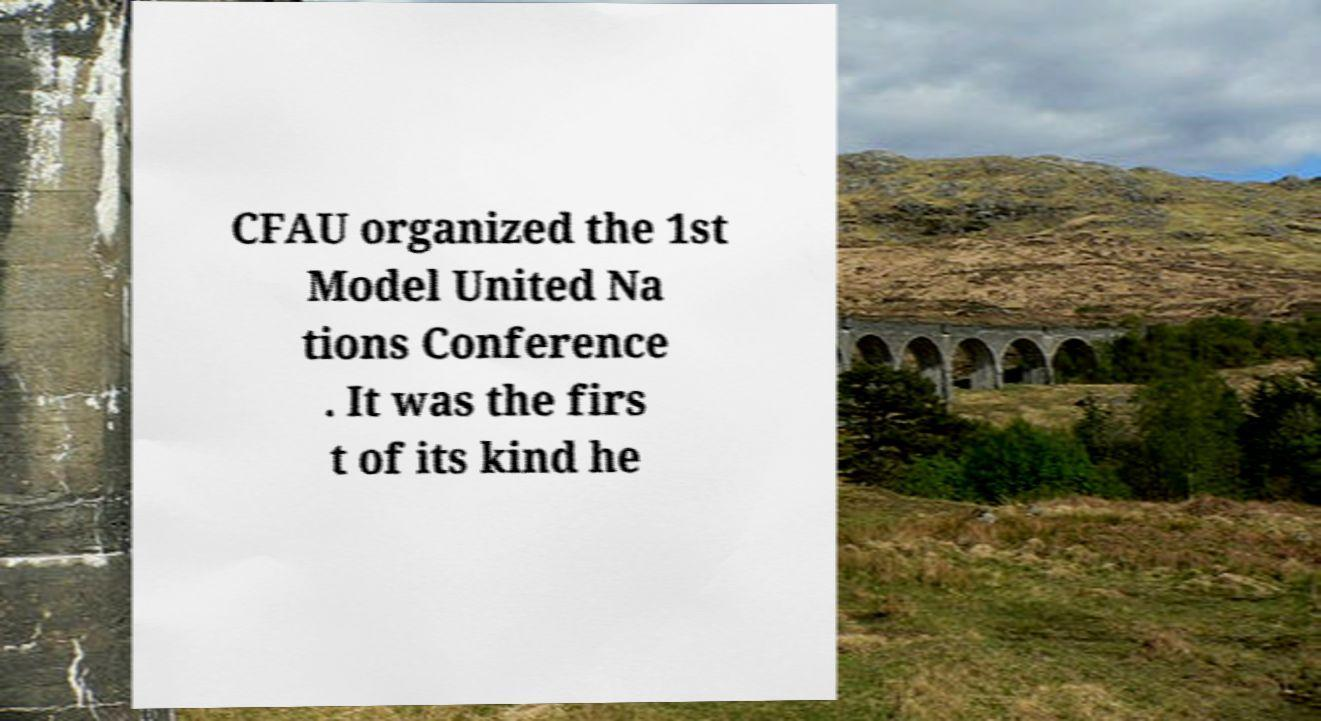Could you extract and type out the text from this image? CFAU organized the 1st Model United Na tions Conference . It was the firs t of its kind he 